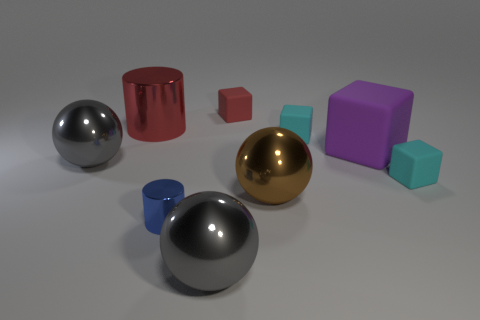Add 1 large matte cubes. How many objects exist? 10 Subtract all spheres. How many objects are left? 6 Subtract all cyan rubber blocks. Subtract all tiny metallic cylinders. How many objects are left? 6 Add 8 big purple matte things. How many big purple matte things are left? 9 Add 5 tiny metal things. How many tiny metal things exist? 6 Subtract 1 red cylinders. How many objects are left? 8 